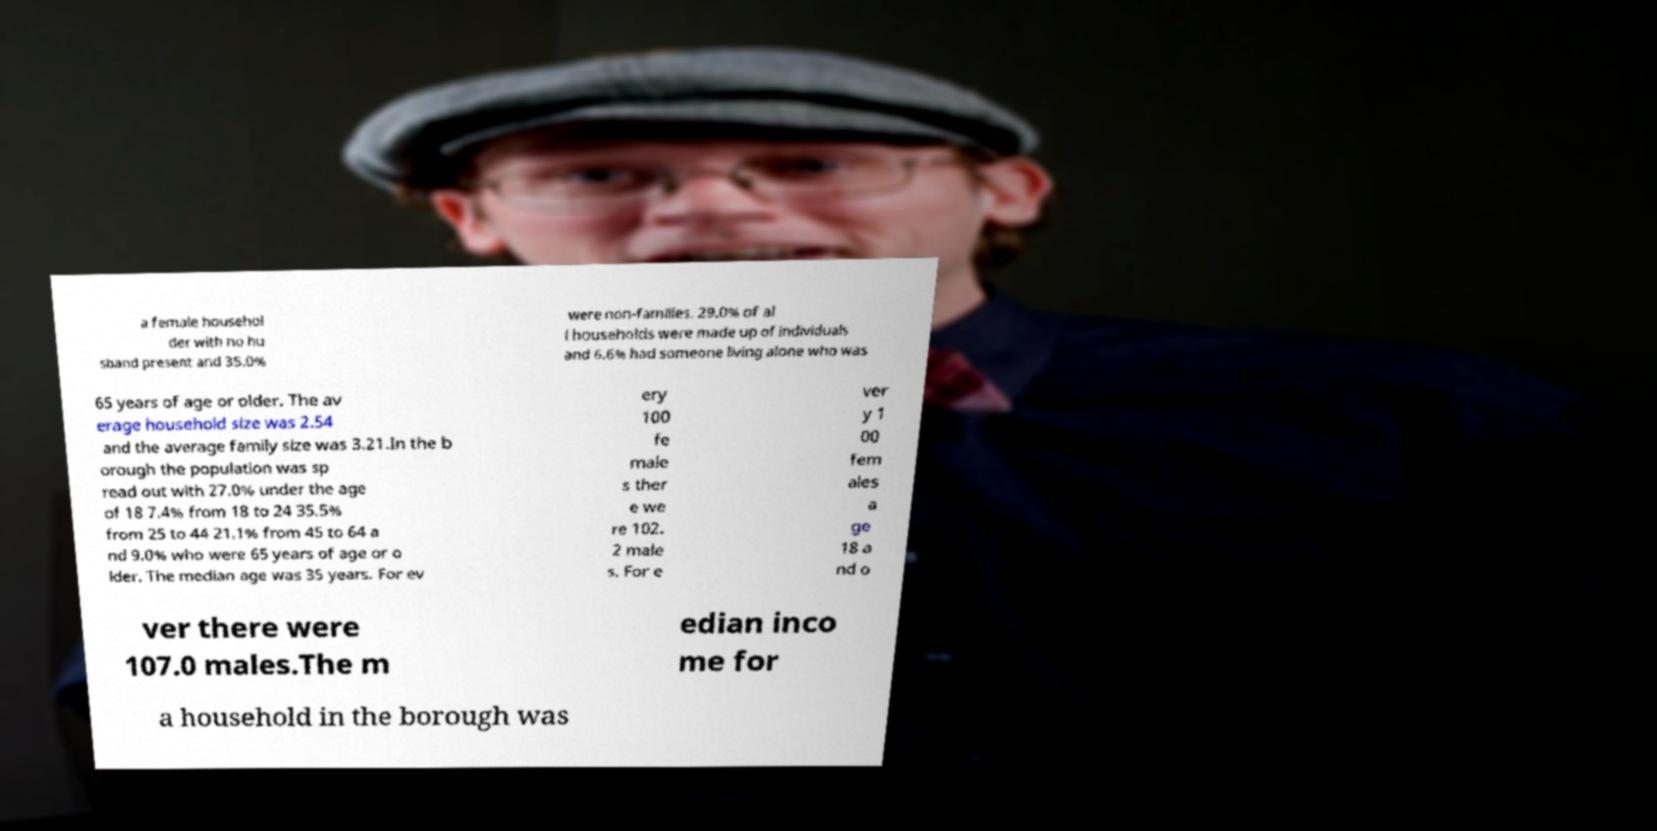Please read and relay the text visible in this image. What does it say? a female househol der with no hu sband present and 35.0% were non-families. 29.0% of al l households were made up of individuals and 6.6% had someone living alone who was 65 years of age or older. The av erage household size was 2.54 and the average family size was 3.21.In the b orough the population was sp read out with 27.0% under the age of 18 7.4% from 18 to 24 35.5% from 25 to 44 21.1% from 45 to 64 a nd 9.0% who were 65 years of age or o lder. The median age was 35 years. For ev ery 100 fe male s ther e we re 102. 2 male s. For e ver y 1 00 fem ales a ge 18 a nd o ver there were 107.0 males.The m edian inco me for a household in the borough was 